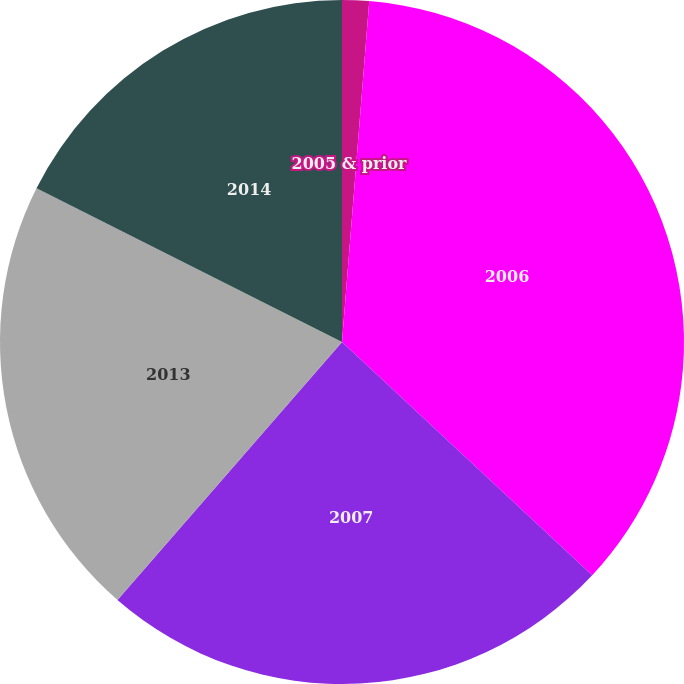Convert chart. <chart><loc_0><loc_0><loc_500><loc_500><pie_chart><fcel>2005 & prior<fcel>2006<fcel>2007<fcel>2013<fcel>2014<nl><fcel>1.27%<fcel>35.67%<fcel>24.46%<fcel>21.02%<fcel>17.58%<nl></chart> 